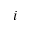Convert formula to latex. <formula><loc_0><loc_0><loc_500><loc_500>i</formula> 